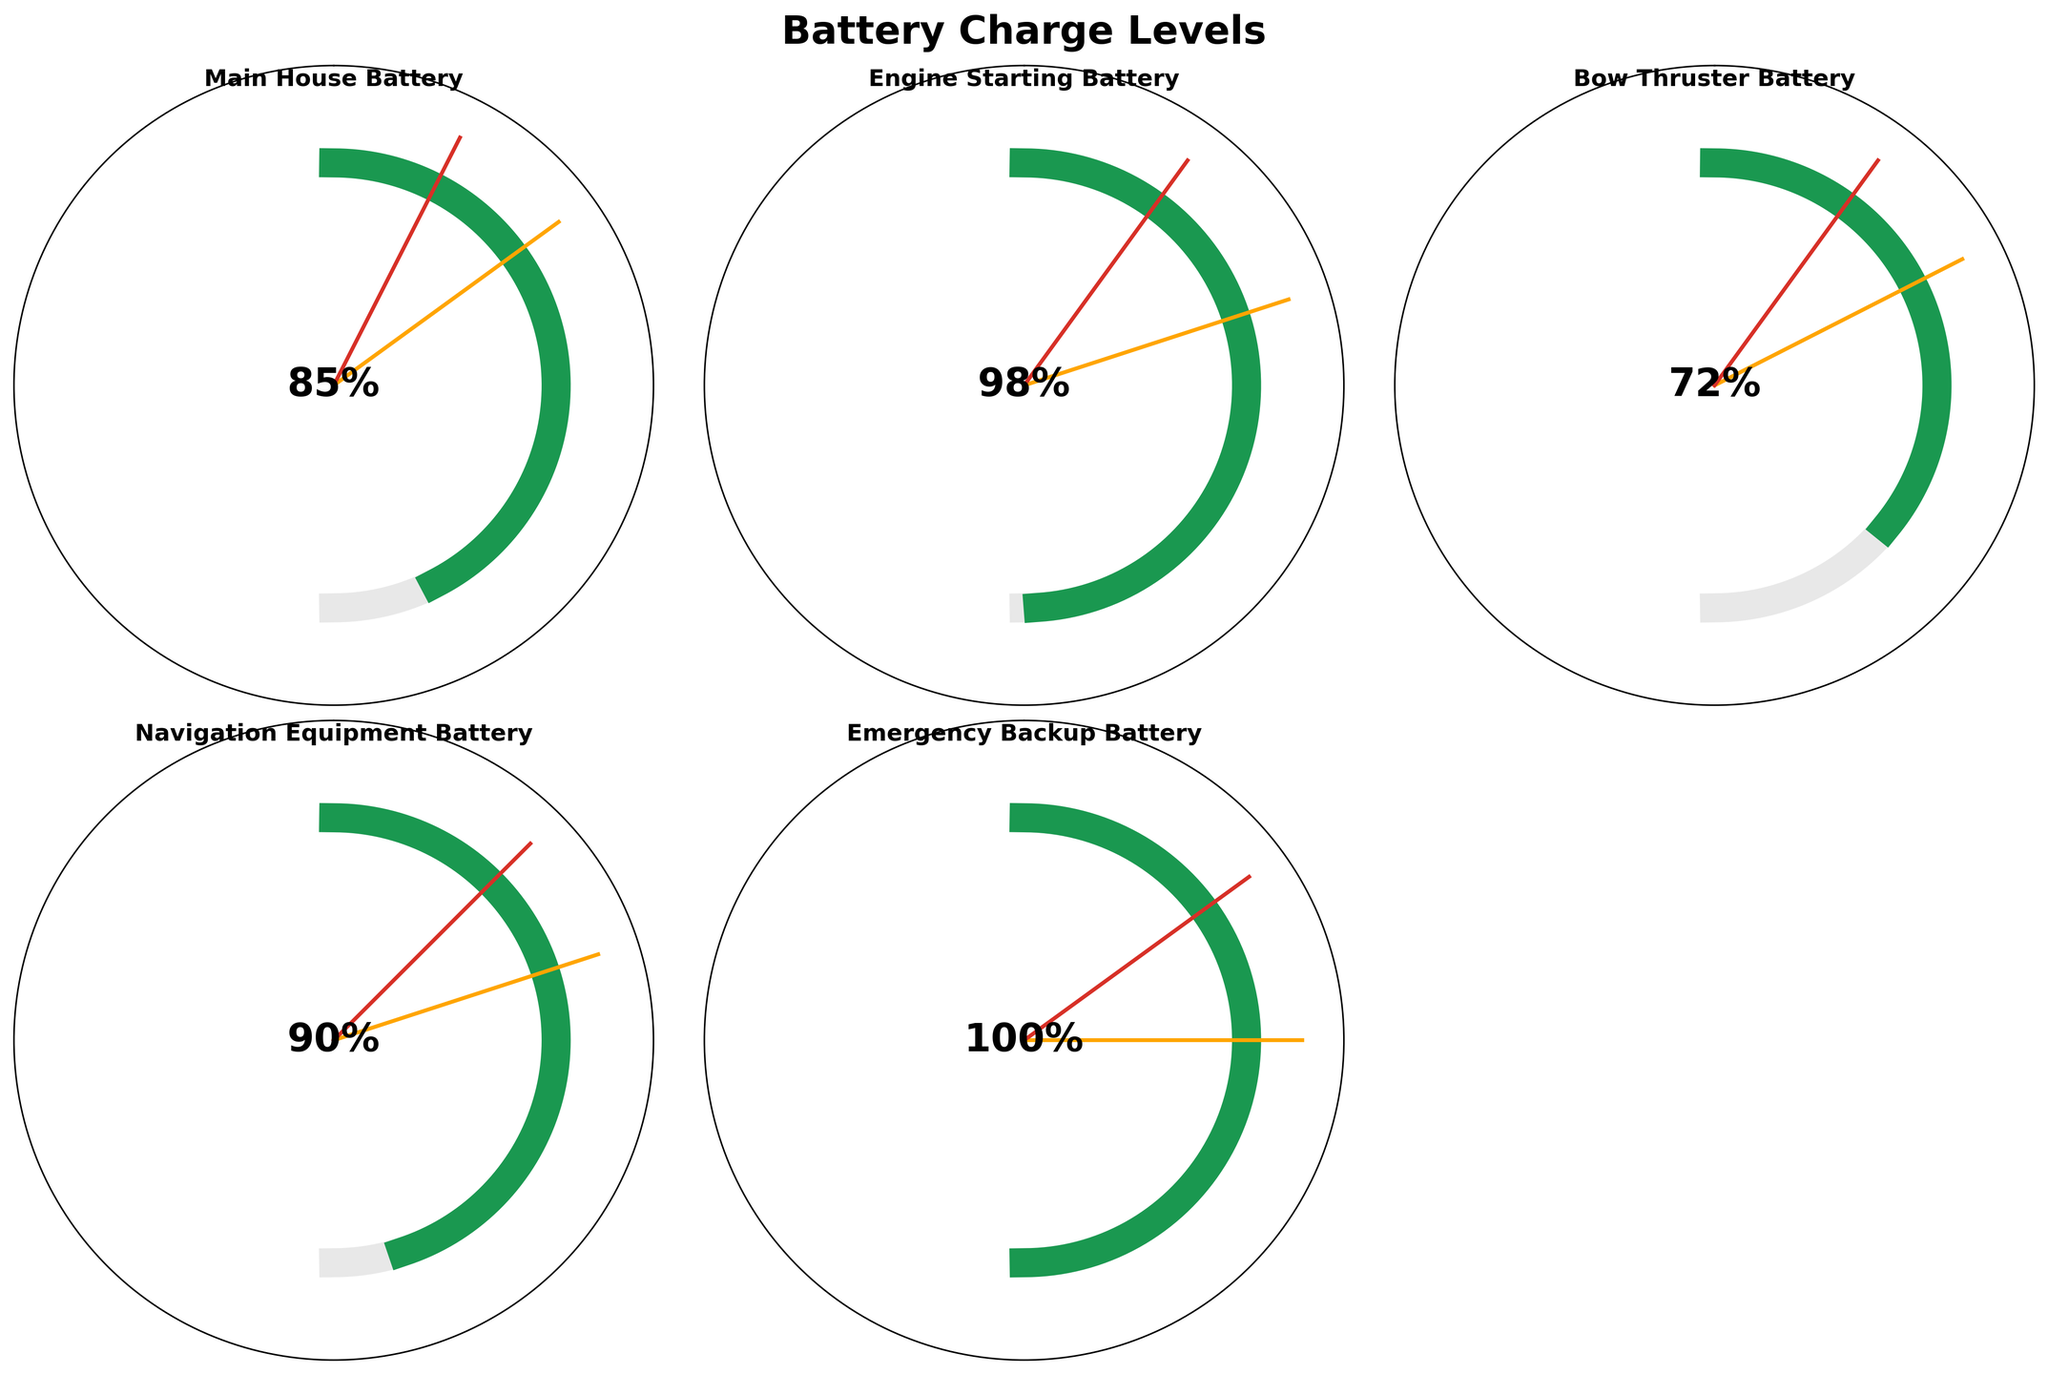Which battery has the highest current charge level? By observing the gauge charts, the highest current charge level is for the "Emergency Backup Battery" at 100%.
Answer: Emergency Backup Battery What is the warning level for the Navigation Equipment Battery? The warning level for the Navigation Equipment Battery is marked with an orange line on its respective gauge chart at 40%.
Answer: 40% Which battery is closest to reaching its critical level? To determine this, compare the current charge levels to the critical levels indicated by red lines. The "Bow Thruster Battery" has a current charge level of 72% with a critical level at 20%, making it the closest.
Answer: Bow Thruster Battery What is the average current charge level across all batteries? Add up all the current charge levels (85 + 98 + 72 + 90 + 100) and divide by the number of batteries (5). The average is (85 + 98 + 72 + 90 + 100) / 5 = 89%.
Answer: 89% Which battery is below its warning level? Compare the current charge levels with their respective warning levels. The "Bow Thruster Battery" has a current charge level of 72% and a warning level of 35%, which is the only battery below its warning level.
Answer: Bow Thruster Battery How many batteries are at least 90% charged? Check each battery's current charge level: Main House Battery (85%), Engine Starting Battery (98%), Bow Thruster Battery (72%), Navigation Equipment Battery (90%), Emergency Backup Battery (100%). There are three batteries (Engine Starting Battery, Navigation Equipment Battery, and Emergency Backup Battery) that are at least 90% charged.
Answer: Three Which battery has the largest difference between its maximum capacity and current charge level? Calculate the difference for each battery: Main House Battery (100 - 85 = 15), Engine Starting Battery (100 - 98 = 2), Bow Thruster Battery (100 - 72 = 28), Navigation Equipment Battery (100 - 90 = 10), Emergency Backup Battery (100 - 100 = 0). The largest difference is 28 for the Bow Thruster Battery.
Answer: Bow Thruster Battery Is the Engine Starting Battery above its warning level? The Engine Starting Battery has a current charge level of 98% and a warning level of 40%, indicating it is above its warning level.
Answer: Yes 